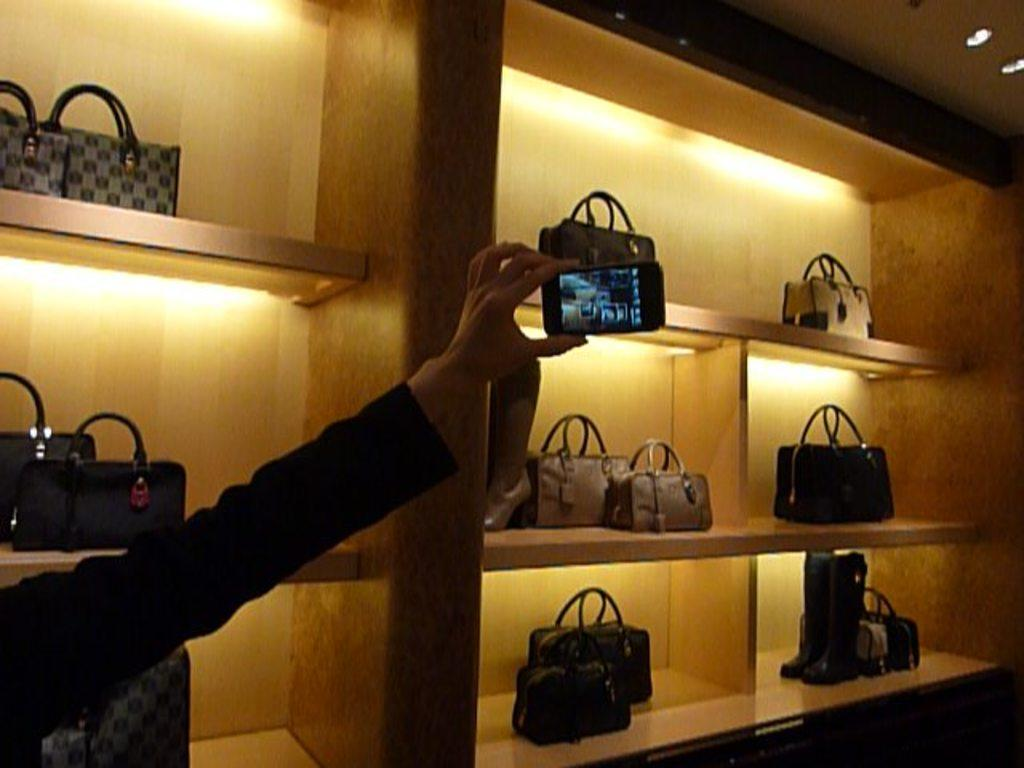What is the person in the image doing? The person in the image is holding a phone. What else can be seen in the image besides the person? There are handbags on shelves and lights visible in the image. What type of doll can be seen smelling the handbags in the image? There is no doll present in the image, and the handbags are on shelves, not being smelled by anyone or anything. 